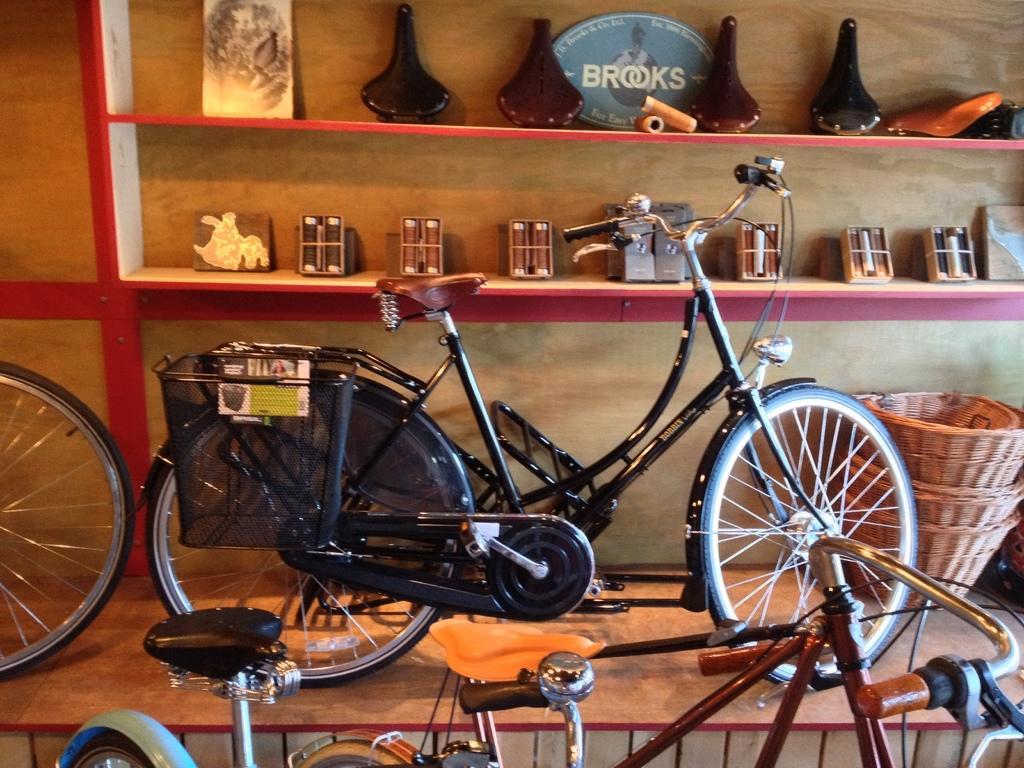Please provide a concise description of this image. In this image we can see some bicycles. On the backside we can see some shelves containing some frames, vases, thread rolls, some boxes and baskets inside it. 